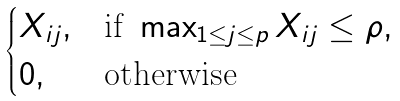Convert formula to latex. <formula><loc_0><loc_0><loc_500><loc_500>\begin{cases} X _ { i j } , & \text {if} \ \max _ { 1 \leq j \leq p } X _ { i j } \leq \rho , \\ 0 , & \text {otherwise} \end{cases}</formula> 